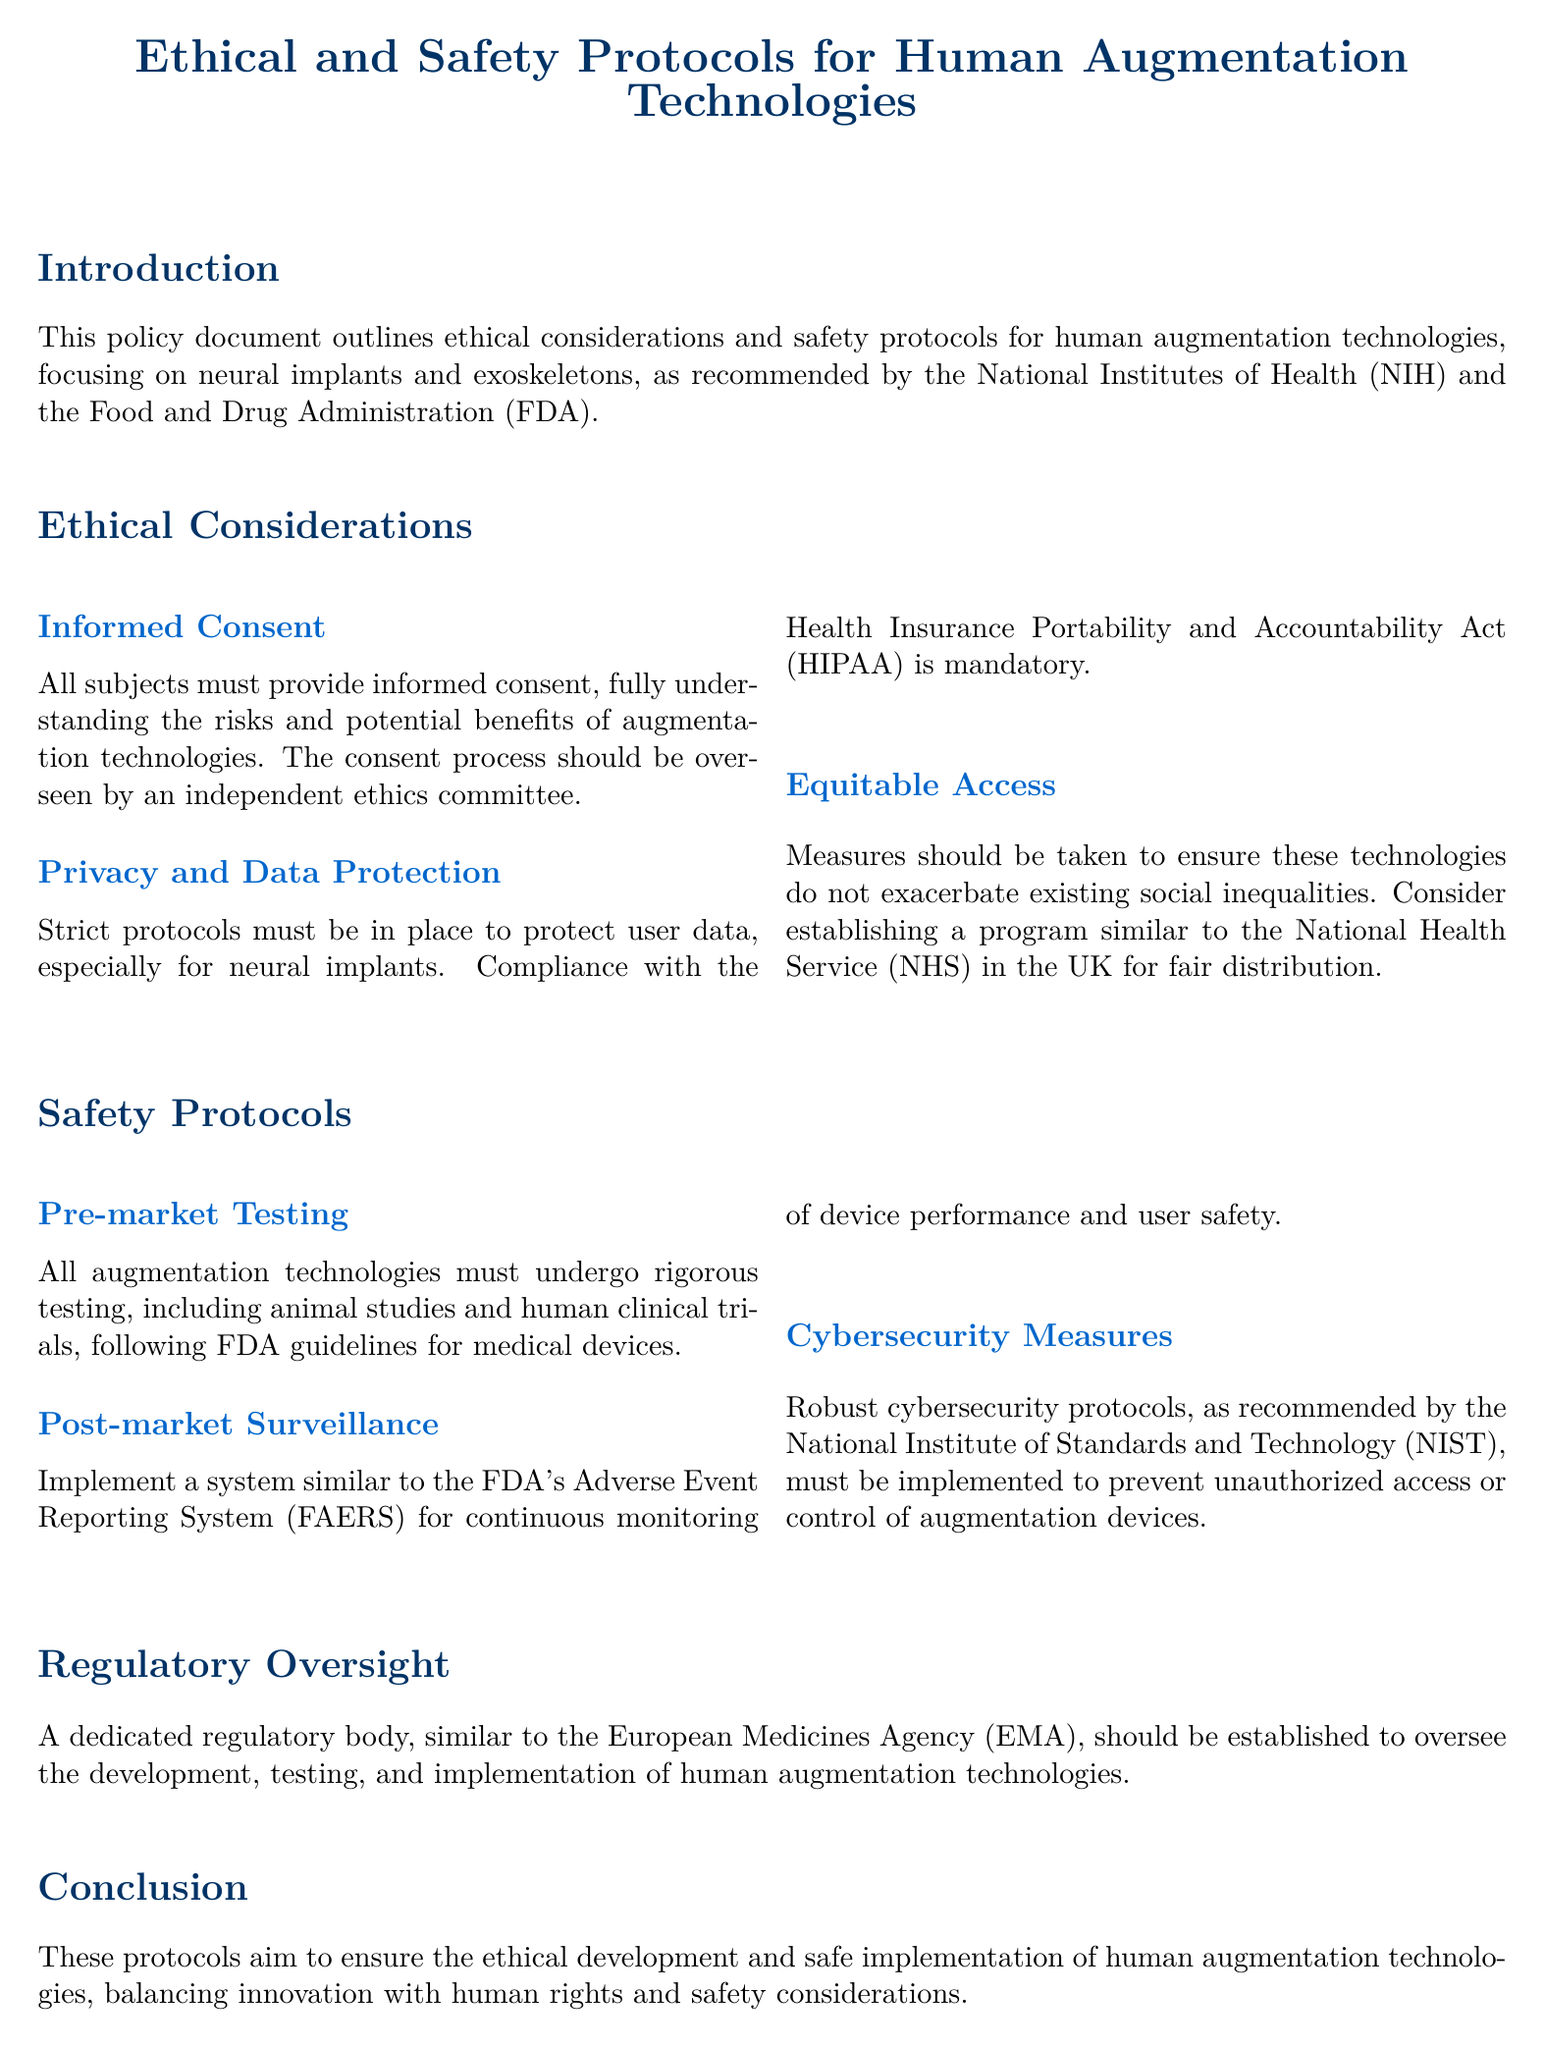What is the title of the document? The title is stated at the beginning of the document and outlines the main focus, which is ethical and safety protocols for human augmentation technologies.
Answer: Ethical and Safety Protocols for Human Augmentation Technologies Who must oversee the informed consent process? The document specifies that the consent process should be overseen by an independent entity to ensure its ethical integrity.
Answer: Independent ethics committee What act must be complied with for data protection? The policy document mentions that compliance with a certain act is mandatory for data protection, particularly concerning user data.
Answer: Health Insurance Portability and Accountability Act (HIPAA) What type of testing is required prior to market release? The document states that all augmentation technologies must undergo a specific type of testing before they can be marketed.
Answer: Pre-market Testing Which system is recommended for continuous monitoring? The recommended system for ongoing surveillance and monitoring of user safety and device performance is mentioned in the safety protocols section.
Answer: Adverse Event Reporting System (FAERS) What type of agency is proposed for regulatory oversight? The document suggests establishing a regulatory body that would function similarly to an existing agency in the European context.
Answer: European Medicines Agency (EMA) What is a key ethical consideration mentioned? The document outlines multiple ethical considerations, and one of them is highlighted as essential for the development of augmentation technologies.
Answer: Informed Consent What should be implemented to prevent unauthorized access? The policy document emphasizes the importance of specific security measures to protect augmentation devices from unauthorized access.
Answer: Cybersecurity Measures 